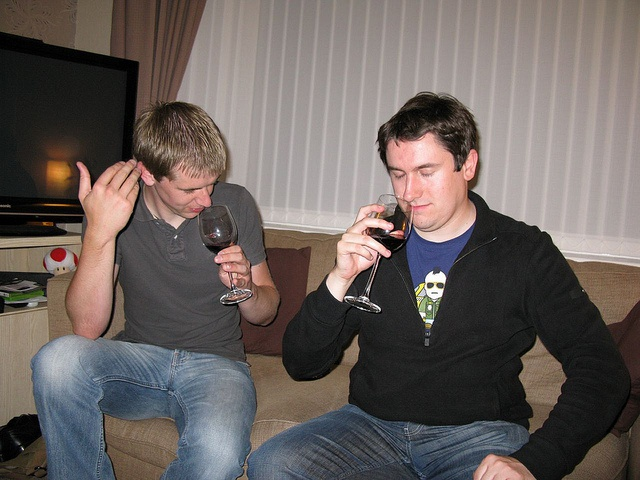Describe the objects in this image and their specific colors. I can see people in black, gray, lightpink, and darkblue tones, people in black, gray, darkgray, and salmon tones, couch in black and gray tones, tv in black, maroon, brown, and gray tones, and wine glass in black, darkgray, and gray tones in this image. 